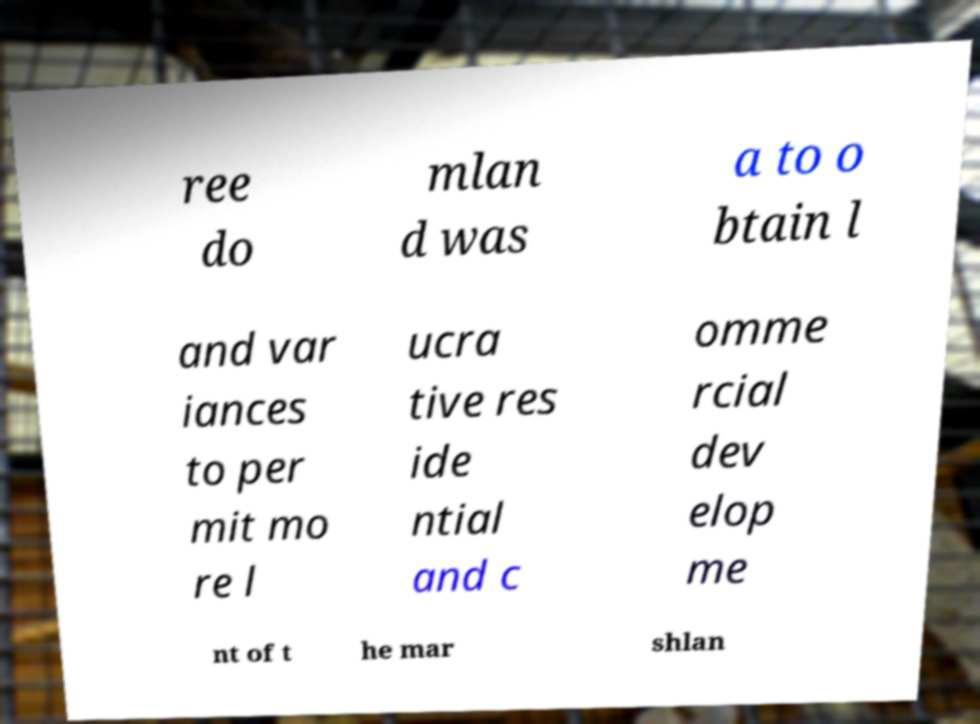Can you read and provide the text displayed in the image?This photo seems to have some interesting text. Can you extract and type it out for me? ree do mlan d was a to o btain l and var iances to per mit mo re l ucra tive res ide ntial and c omme rcial dev elop me nt of t he mar shlan 